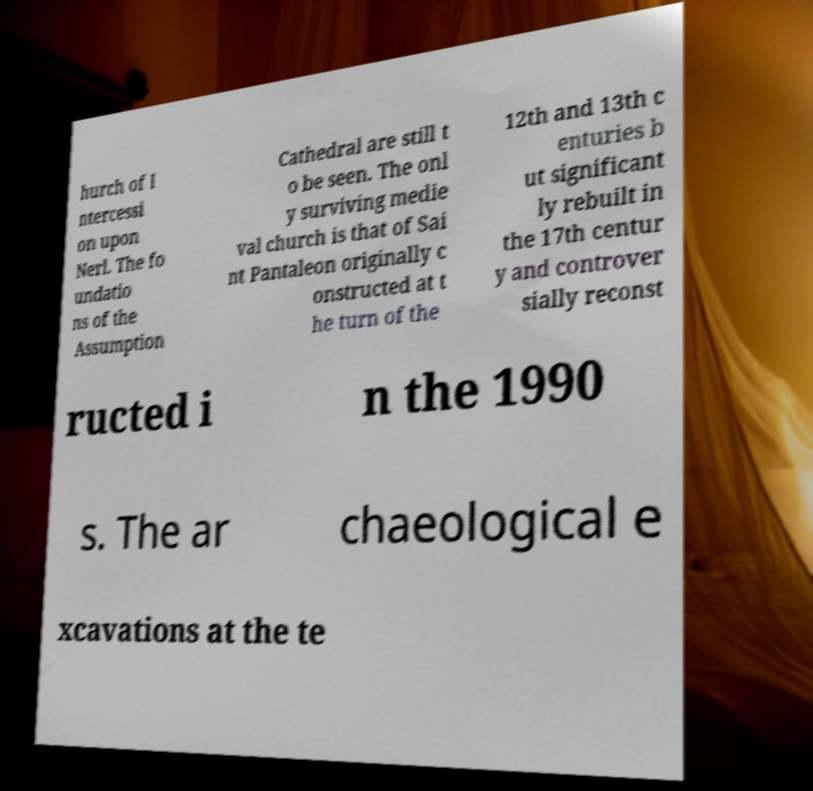What messages or text are displayed in this image? I need them in a readable, typed format. hurch of I ntercessi on upon Nerl. The fo undatio ns of the Assumption Cathedral are still t o be seen. The onl y surviving medie val church is that of Sai nt Pantaleon originally c onstructed at t he turn of the 12th and 13th c enturies b ut significant ly rebuilt in the 17th centur y and controver sially reconst ructed i n the 1990 s. The ar chaeological e xcavations at the te 